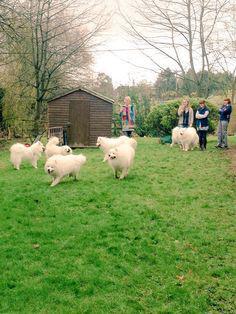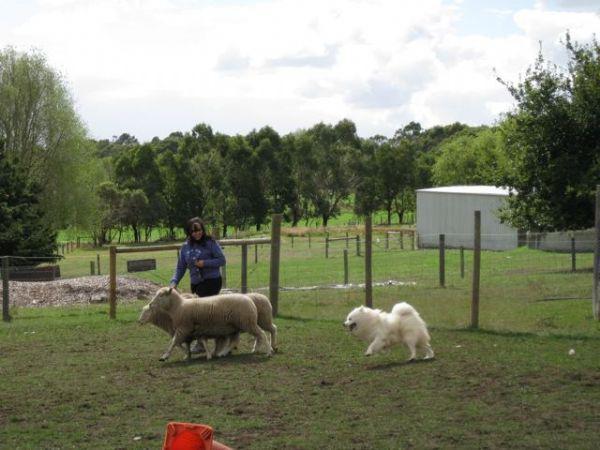The first image is the image on the left, the second image is the image on the right. For the images displayed, is the sentence "In one image, a woman is shown with a white dog and three sheep." factually correct? Answer yes or no. Yes. The first image is the image on the left, the second image is the image on the right. Considering the images on both sides, is "At least one image shows a person in a vehicle behind at least one dog, going down a lane." valid? Answer yes or no. No. 